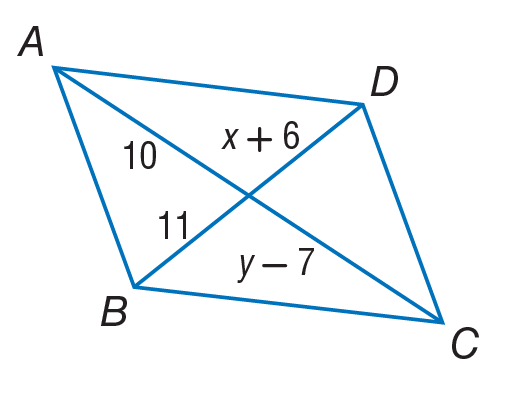Question: Use parallelogram to, find y.
Choices:
A. 5
B. 10
C. 11
D. 17
Answer with the letter. Answer: D Question: Use parallelogram to, find x.
Choices:
A. 5
B. 10
C. 11
D. 17
Answer with the letter. Answer: A 